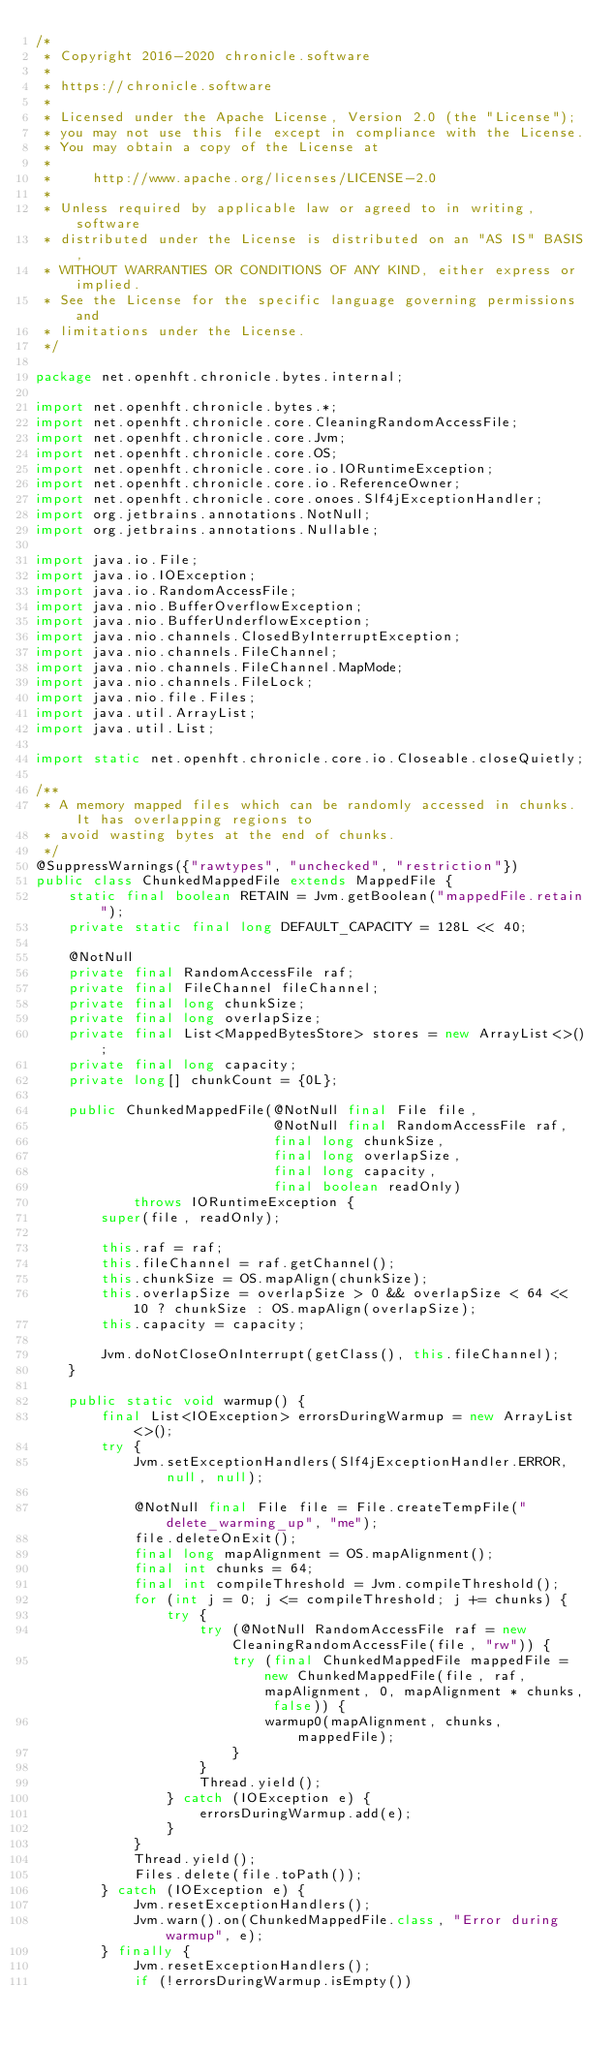<code> <loc_0><loc_0><loc_500><loc_500><_Java_>/*
 * Copyright 2016-2020 chronicle.software
 *
 * https://chronicle.software
 *
 * Licensed under the Apache License, Version 2.0 (the "License");
 * you may not use this file except in compliance with the License.
 * You may obtain a copy of the License at
 *
 *     http://www.apache.org/licenses/LICENSE-2.0
 *
 * Unless required by applicable law or agreed to in writing, software
 * distributed under the License is distributed on an "AS IS" BASIS,
 * WITHOUT WARRANTIES OR CONDITIONS OF ANY KIND, either express or implied.
 * See the License for the specific language governing permissions and
 * limitations under the License.
 */

package net.openhft.chronicle.bytes.internal;

import net.openhft.chronicle.bytes.*;
import net.openhft.chronicle.core.CleaningRandomAccessFile;
import net.openhft.chronicle.core.Jvm;
import net.openhft.chronicle.core.OS;
import net.openhft.chronicle.core.io.IORuntimeException;
import net.openhft.chronicle.core.io.ReferenceOwner;
import net.openhft.chronicle.core.onoes.Slf4jExceptionHandler;
import org.jetbrains.annotations.NotNull;
import org.jetbrains.annotations.Nullable;

import java.io.File;
import java.io.IOException;
import java.io.RandomAccessFile;
import java.nio.BufferOverflowException;
import java.nio.BufferUnderflowException;
import java.nio.channels.ClosedByInterruptException;
import java.nio.channels.FileChannel;
import java.nio.channels.FileChannel.MapMode;
import java.nio.channels.FileLock;
import java.nio.file.Files;
import java.util.ArrayList;
import java.util.List;

import static net.openhft.chronicle.core.io.Closeable.closeQuietly;

/**
 * A memory mapped files which can be randomly accessed in chunks. It has overlapping regions to
 * avoid wasting bytes at the end of chunks.
 */
@SuppressWarnings({"rawtypes", "unchecked", "restriction"})
public class ChunkedMappedFile extends MappedFile {
    static final boolean RETAIN = Jvm.getBoolean("mappedFile.retain");
    private static final long DEFAULT_CAPACITY = 128L << 40;

    @NotNull
    private final RandomAccessFile raf;
    private final FileChannel fileChannel;
    private final long chunkSize;
    private final long overlapSize;
    private final List<MappedBytesStore> stores = new ArrayList<>();
    private final long capacity;
    private long[] chunkCount = {0L};

    public ChunkedMappedFile(@NotNull final File file,
                             @NotNull final RandomAccessFile raf,
                             final long chunkSize,
                             final long overlapSize,
                             final long capacity,
                             final boolean readOnly)
            throws IORuntimeException {
        super(file, readOnly);

        this.raf = raf;
        this.fileChannel = raf.getChannel();
        this.chunkSize = OS.mapAlign(chunkSize);
        this.overlapSize = overlapSize > 0 && overlapSize < 64 << 10 ? chunkSize : OS.mapAlign(overlapSize);
        this.capacity = capacity;

        Jvm.doNotCloseOnInterrupt(getClass(), this.fileChannel);
    }

    public static void warmup() {
        final List<IOException> errorsDuringWarmup = new ArrayList<>();
        try {
            Jvm.setExceptionHandlers(Slf4jExceptionHandler.ERROR, null, null);

            @NotNull final File file = File.createTempFile("delete_warming_up", "me");
            file.deleteOnExit();
            final long mapAlignment = OS.mapAlignment();
            final int chunks = 64;
            final int compileThreshold = Jvm.compileThreshold();
            for (int j = 0; j <= compileThreshold; j += chunks) {
                try {
                    try (@NotNull RandomAccessFile raf = new CleaningRandomAccessFile(file, "rw")) {
                        try (final ChunkedMappedFile mappedFile = new ChunkedMappedFile(file, raf, mapAlignment, 0, mapAlignment * chunks, false)) {
                            warmup0(mapAlignment, chunks, mappedFile);
                        }
                    }
                    Thread.yield();
                } catch (IOException e) {
                    errorsDuringWarmup.add(e);
                }
            }
            Thread.yield();
            Files.delete(file.toPath());
        } catch (IOException e) {
            Jvm.resetExceptionHandlers();
            Jvm.warn().on(ChunkedMappedFile.class, "Error during warmup", e);
        } finally {
            Jvm.resetExceptionHandlers();
            if (!errorsDuringWarmup.isEmpty())</code> 